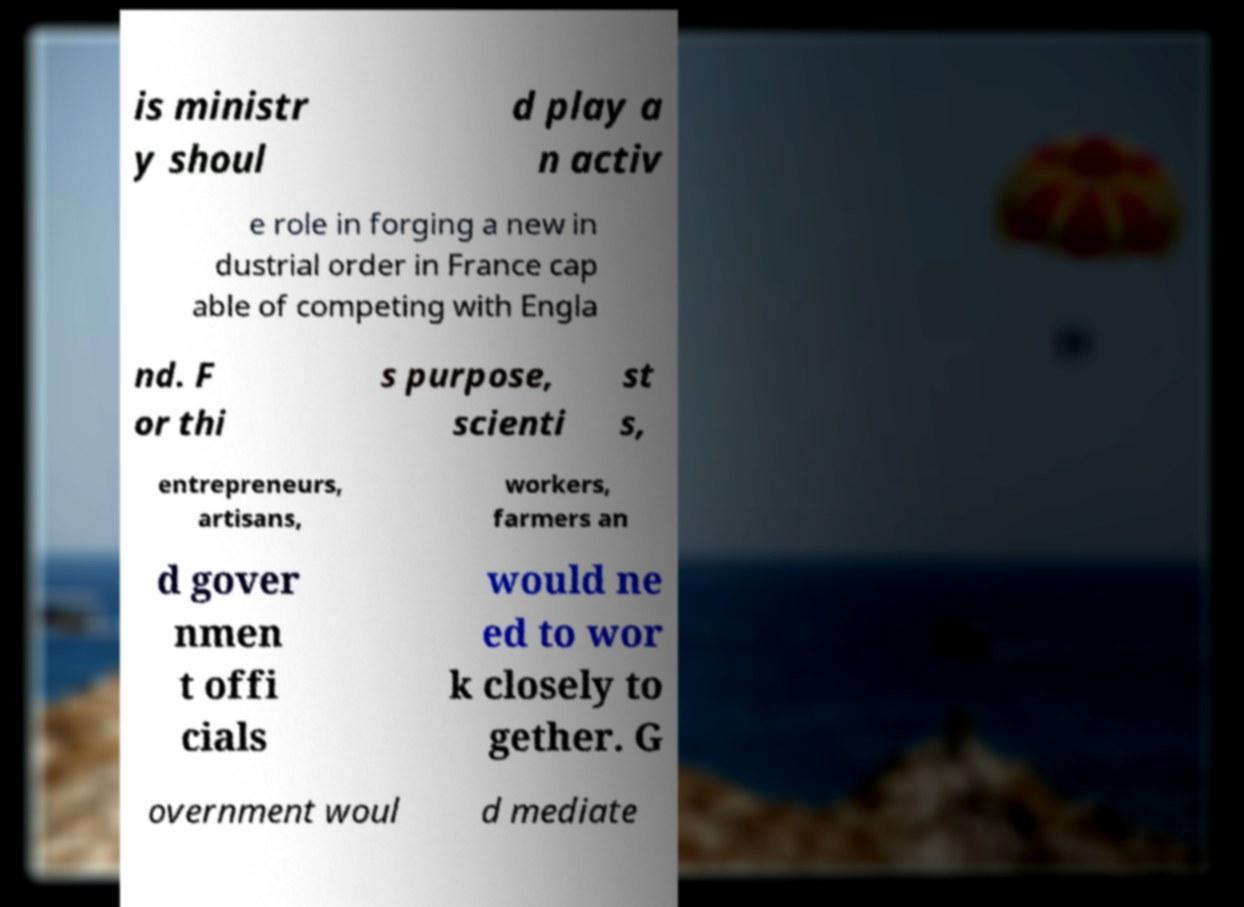Can you read and provide the text displayed in the image?This photo seems to have some interesting text. Can you extract and type it out for me? is ministr y shoul d play a n activ e role in forging a new in dustrial order in France cap able of competing with Engla nd. F or thi s purpose, scienti st s, entrepreneurs, artisans, workers, farmers an d gover nmen t offi cials would ne ed to wor k closely to gether. G overnment woul d mediate 